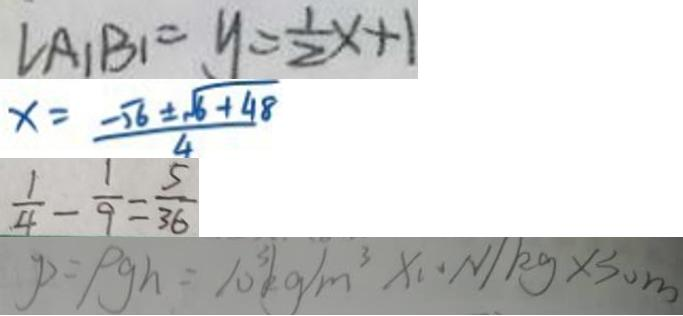Convert formula to latex. <formula><loc_0><loc_0><loc_500><loc_500>\angle A _ { 1 } B _ { 1 } = y = \frac { 1 } { 2 } x + 1 
 x = \frac { - \sqrt { 6 } \pm \sqrt { 6 + 4 8 } } { 4 } 
 \frac { 1 } { 4 } - \frac { 1 } { 9 } = \frac { 5 } { 3 6 } 
 P = \rho g h = 1 0 ^ { 3 } k g / m ^ { 3 } \times 1 0 N / k g \times 3 0 m</formula> 